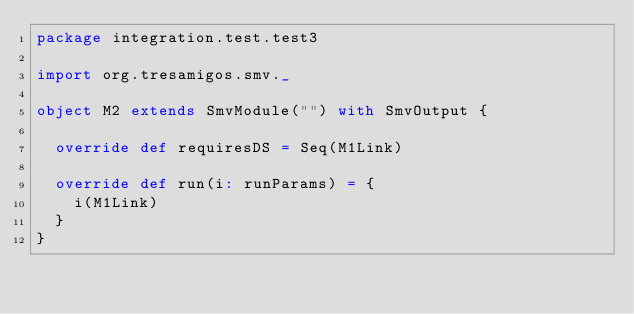Convert code to text. <code><loc_0><loc_0><loc_500><loc_500><_Scala_>package integration.test.test3

import org.tresamigos.smv._

object M2 extends SmvModule("") with SmvOutput {

  override def requiresDS = Seq(M1Link)

  override def run(i: runParams) = {
    i(M1Link)
  }
}
</code> 